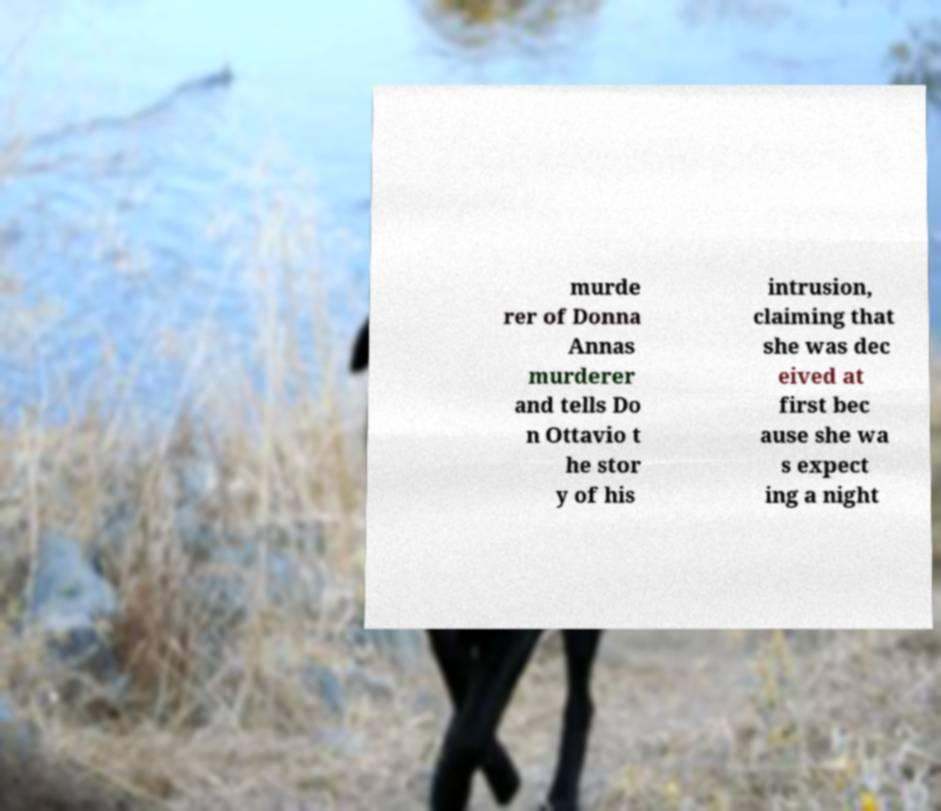Can you read and provide the text displayed in the image?This photo seems to have some interesting text. Can you extract and type it out for me? murde rer of Donna Annas murderer and tells Do n Ottavio t he stor y of his intrusion, claiming that she was dec eived at first bec ause she wa s expect ing a night 